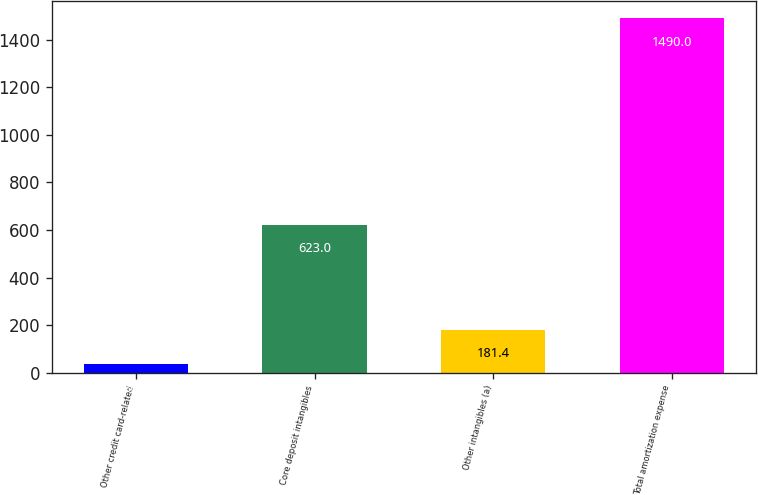Convert chart to OTSL. <chart><loc_0><loc_0><loc_500><loc_500><bar_chart><fcel>Other credit card-related<fcel>Core deposit intangibles<fcel>Other intangibles (a)<fcel>Total amortization expense<nl><fcel>36<fcel>623<fcel>181.4<fcel>1490<nl></chart> 